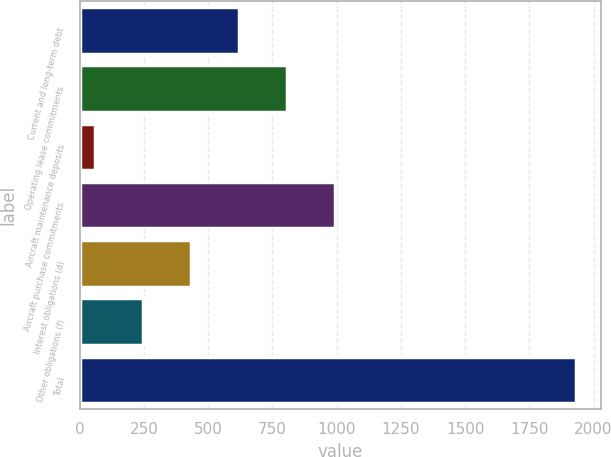<chart> <loc_0><loc_0><loc_500><loc_500><bar_chart><fcel>Current and long-term debt<fcel>Operating lease commitments<fcel>Aircraft maintenance deposits<fcel>Aircraft purchase commitments<fcel>Interest obligations (d)<fcel>Other obligations (f)<fcel>Total<nl><fcel>620.6<fcel>807.8<fcel>59<fcel>995<fcel>433.4<fcel>246.2<fcel>1931<nl></chart> 